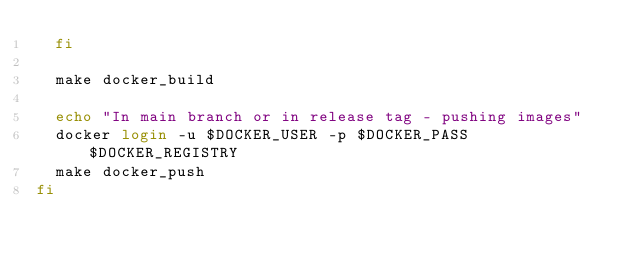Convert code to text. <code><loc_0><loc_0><loc_500><loc_500><_Bash_>  fi

  make docker_build

  echo "In main branch or in release tag - pushing images"
  docker login -u $DOCKER_USER -p $DOCKER_PASS $DOCKER_REGISTRY
  make docker_push
fi
</code> 